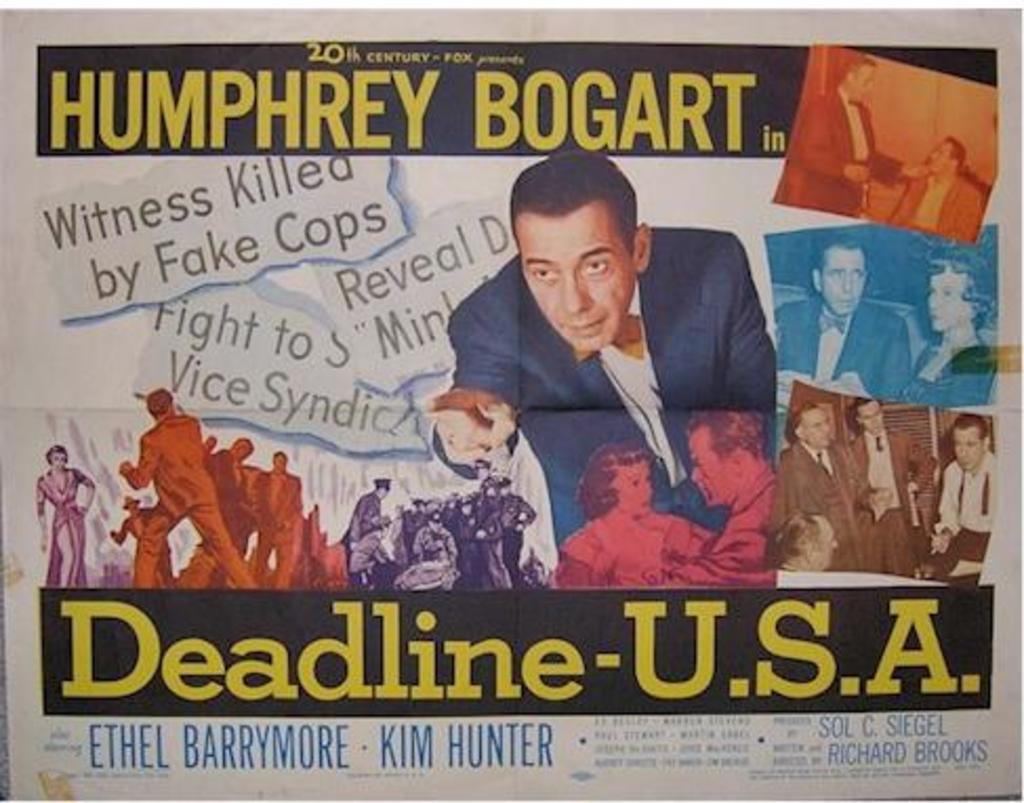What happened to the witness?
Provide a short and direct response. Killed. Killed by fake cops?
Your response must be concise. Yes. 